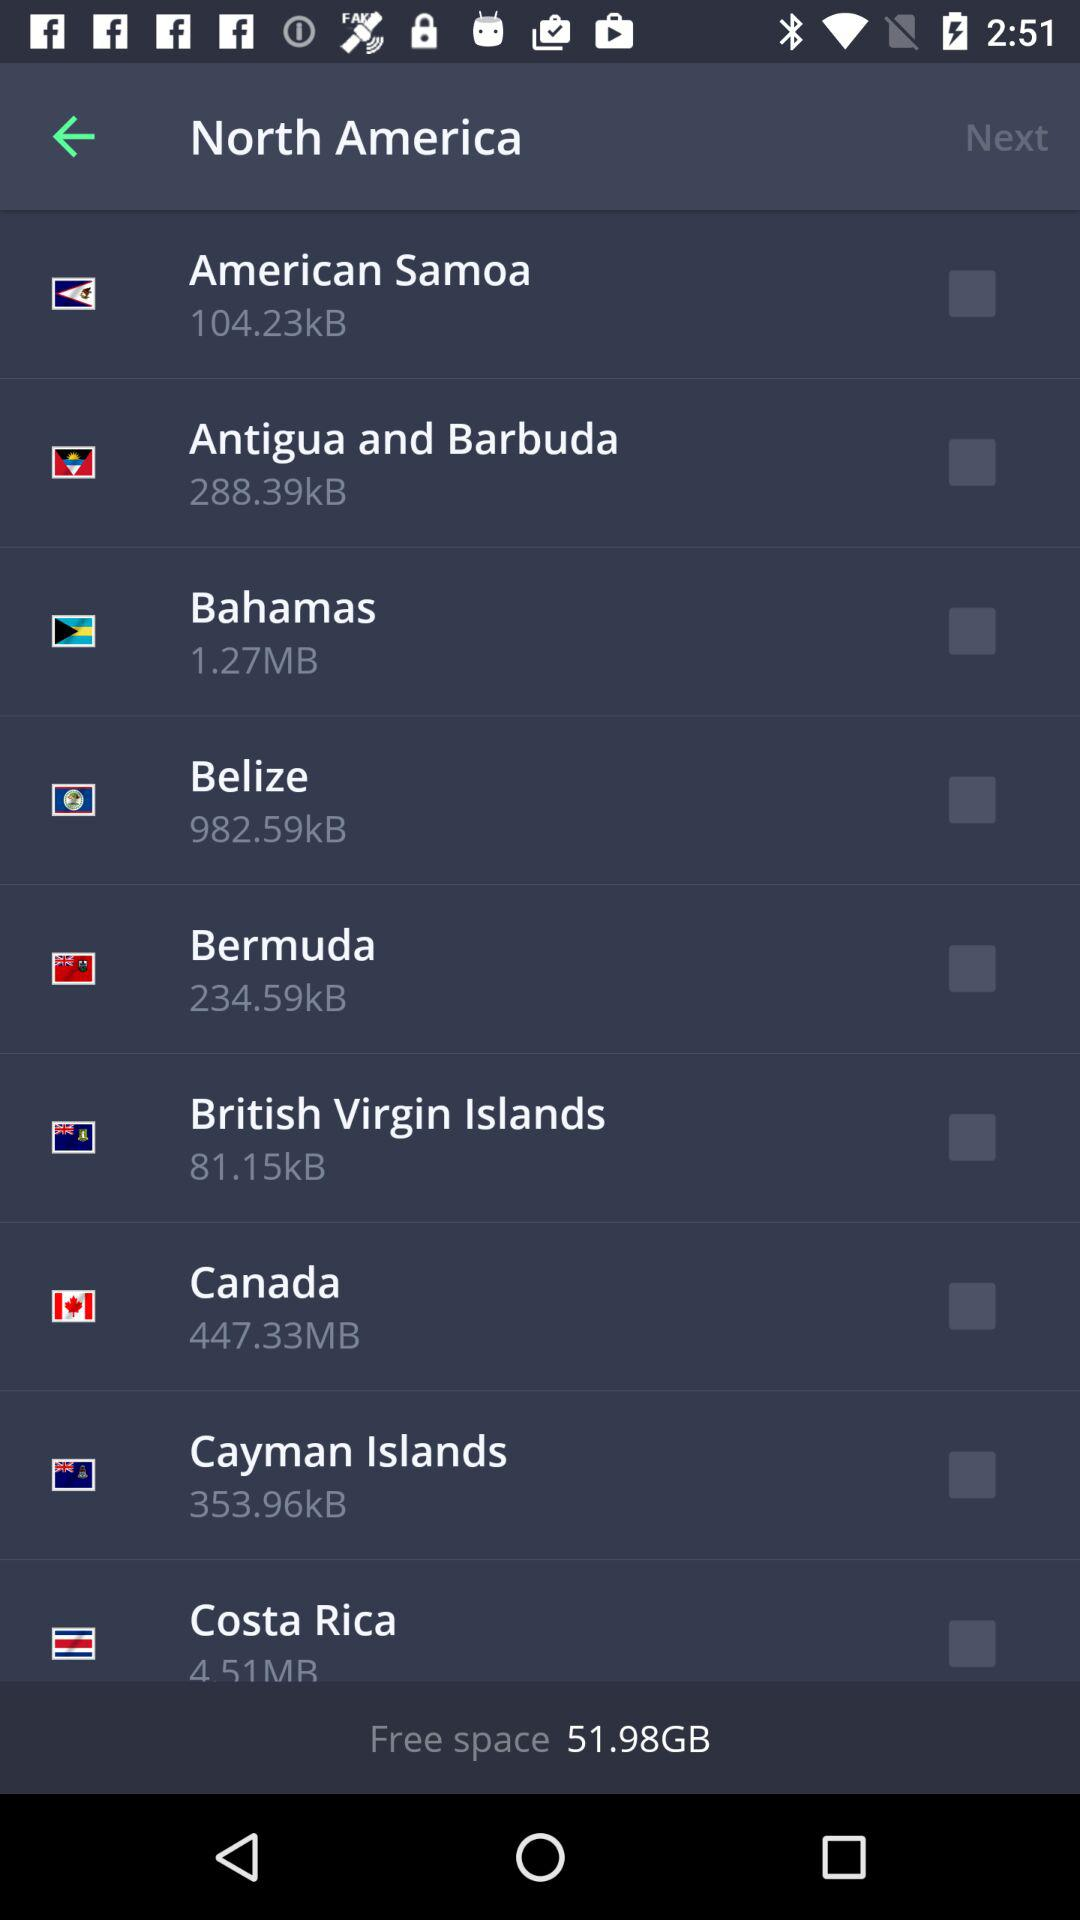How much free space is there? There is 51.98 GB of free space. 